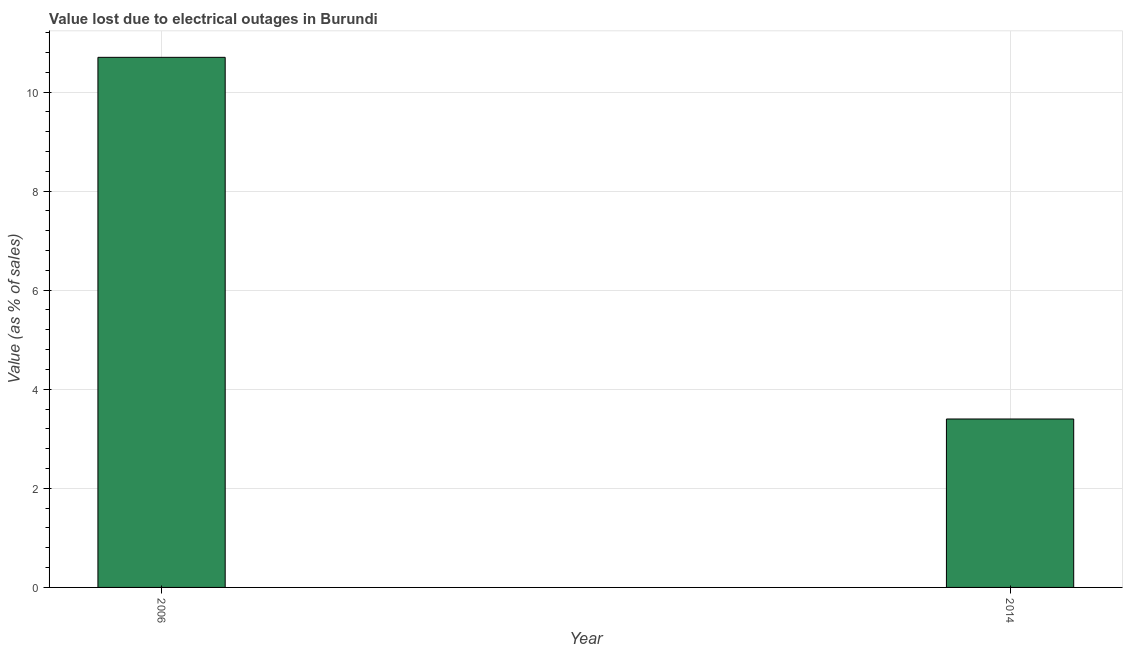Does the graph contain any zero values?
Offer a very short reply. No. What is the title of the graph?
Provide a short and direct response. Value lost due to electrical outages in Burundi. What is the label or title of the X-axis?
Provide a succinct answer. Year. What is the label or title of the Y-axis?
Give a very brief answer. Value (as % of sales). What is the value lost due to electrical outages in 2014?
Offer a very short reply. 3.4. What is the sum of the value lost due to electrical outages?
Your answer should be very brief. 14.1. What is the difference between the value lost due to electrical outages in 2006 and 2014?
Your answer should be compact. 7.3. What is the average value lost due to electrical outages per year?
Ensure brevity in your answer.  7.05. What is the median value lost due to electrical outages?
Your response must be concise. 7.05. Do a majority of the years between 2014 and 2006 (inclusive) have value lost due to electrical outages greater than 6 %?
Your answer should be very brief. No. What is the ratio of the value lost due to electrical outages in 2006 to that in 2014?
Your answer should be compact. 3.15. Are all the bars in the graph horizontal?
Provide a short and direct response. No. What is the difference between two consecutive major ticks on the Y-axis?
Give a very brief answer. 2. What is the difference between the Value (as % of sales) in 2006 and 2014?
Ensure brevity in your answer.  7.3. What is the ratio of the Value (as % of sales) in 2006 to that in 2014?
Provide a short and direct response. 3.15. 